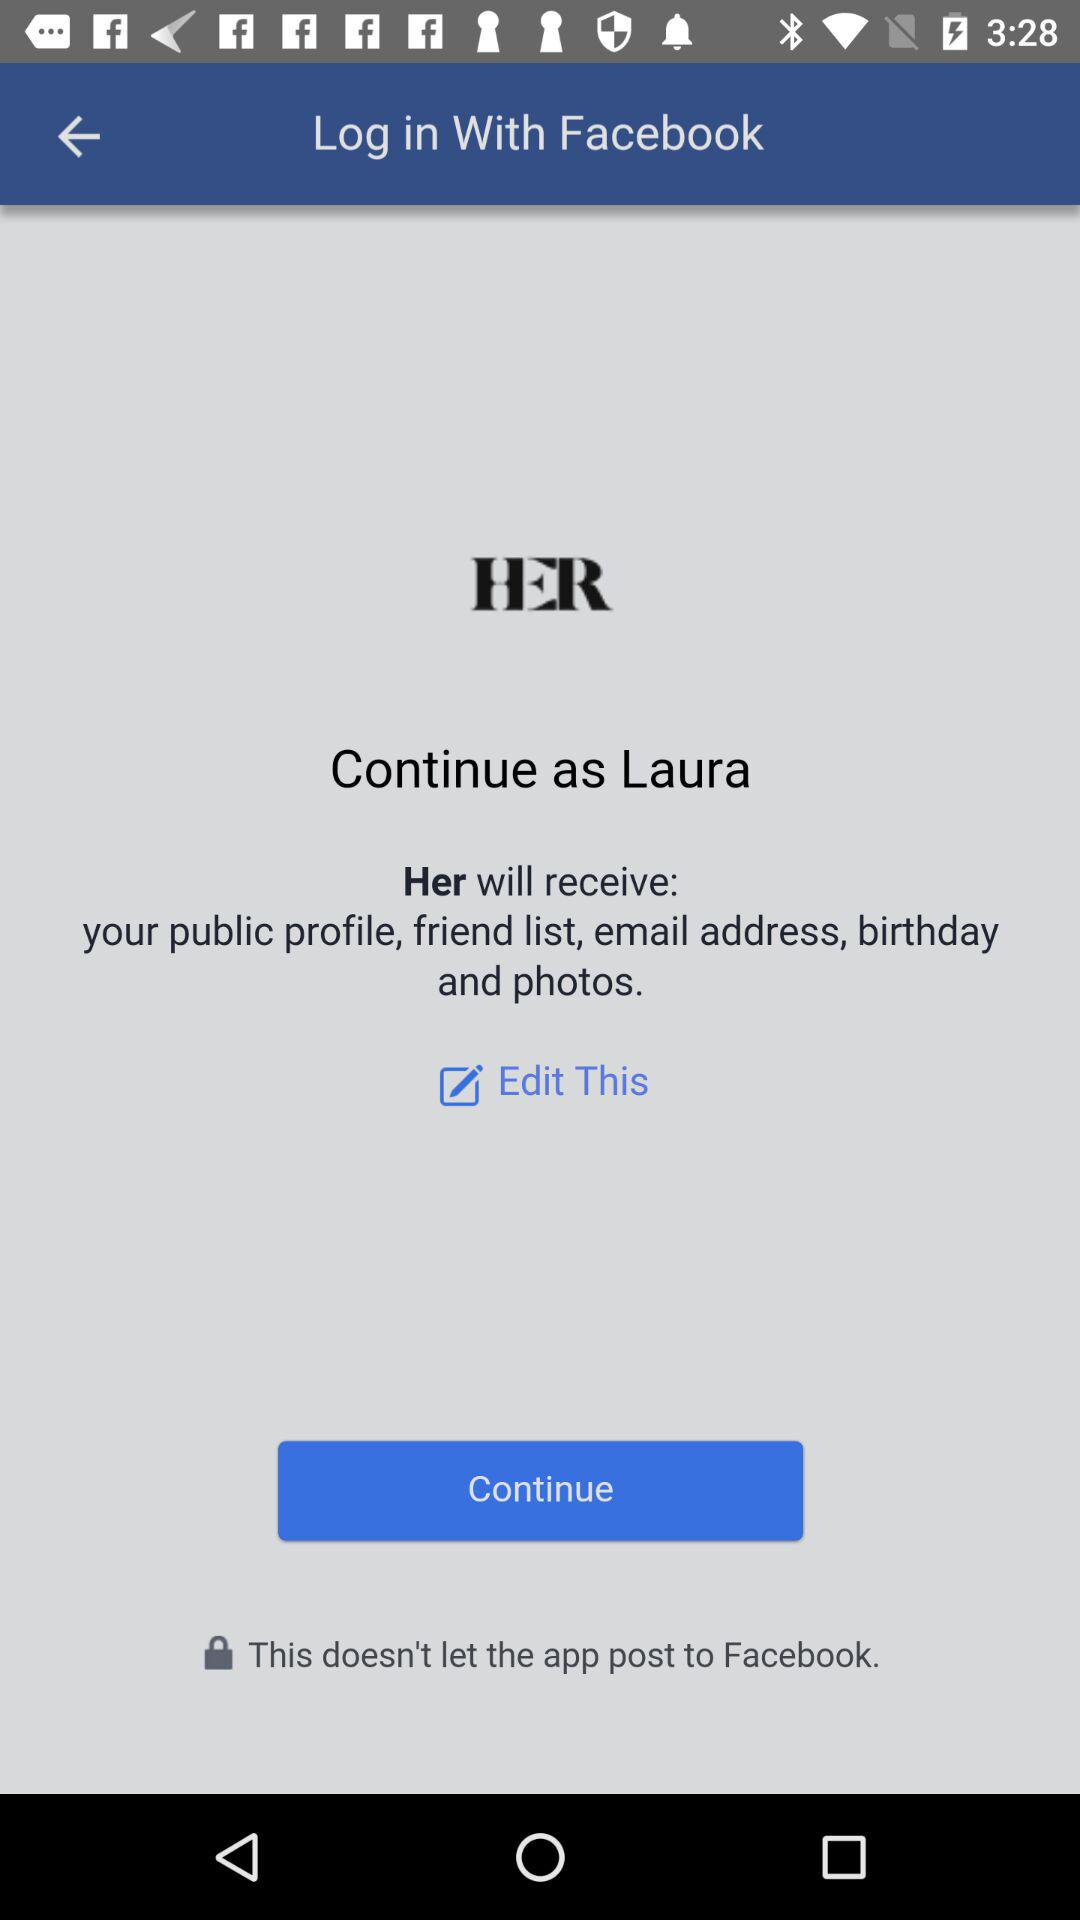What application is asking for permission? The application asking for permission is "Her". 